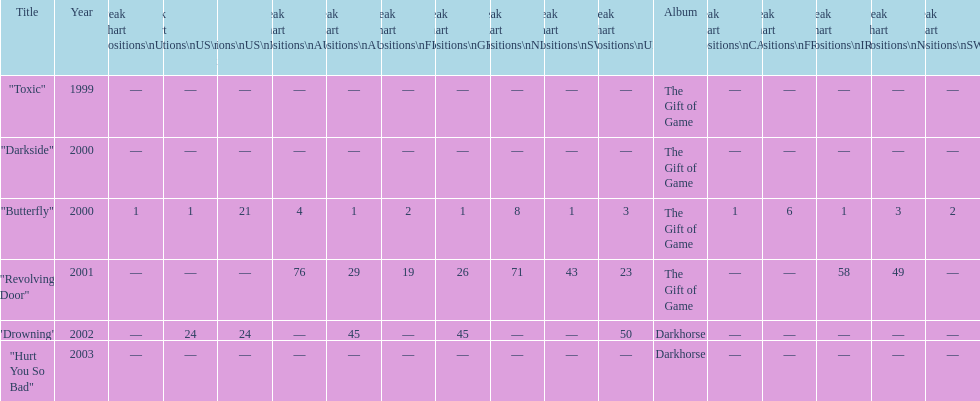When did "drowning" peak at 24 in the us alternate group? 2002. 